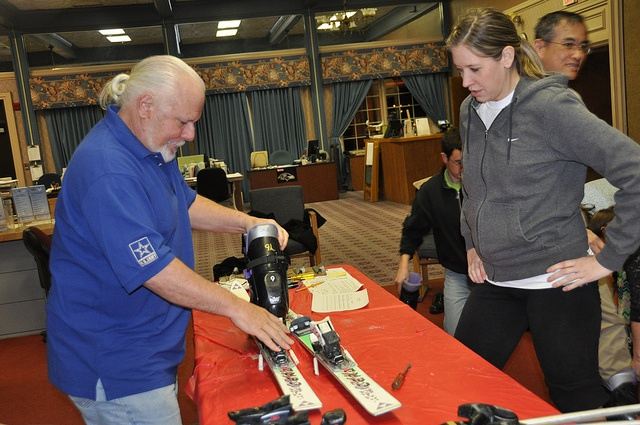Describe the objects in this image and their specific colors. I can see people in black, gray, and tan tones, people in black, blue, navy, darkblue, and darkgray tones, people in black, gray, and maroon tones, skis in black, beige, darkgray, and tan tones, and chair in black, maroon, and brown tones in this image. 